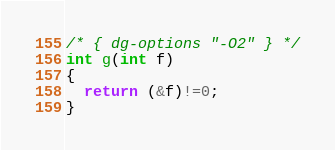Convert code to text. <code><loc_0><loc_0><loc_500><loc_500><_C_>/* { dg-options "-O2" } */
int g(int f)
{
  return (&f)!=0;
}

</code> 